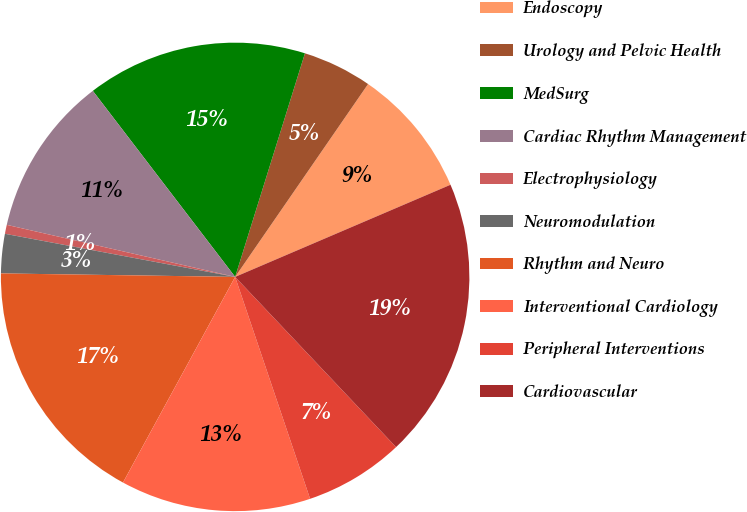Convert chart. <chart><loc_0><loc_0><loc_500><loc_500><pie_chart><fcel>Endoscopy<fcel>Urology and Pelvic Health<fcel>MedSurg<fcel>Cardiac Rhythm Management<fcel>Electrophysiology<fcel>Neuromodulation<fcel>Rhythm and Neuro<fcel>Interventional Cardiology<fcel>Peripheral Interventions<fcel>Cardiovascular<nl><fcel>8.96%<fcel>4.79%<fcel>15.21%<fcel>11.04%<fcel>0.62%<fcel>2.71%<fcel>17.29%<fcel>13.13%<fcel>6.87%<fcel>19.38%<nl></chart> 